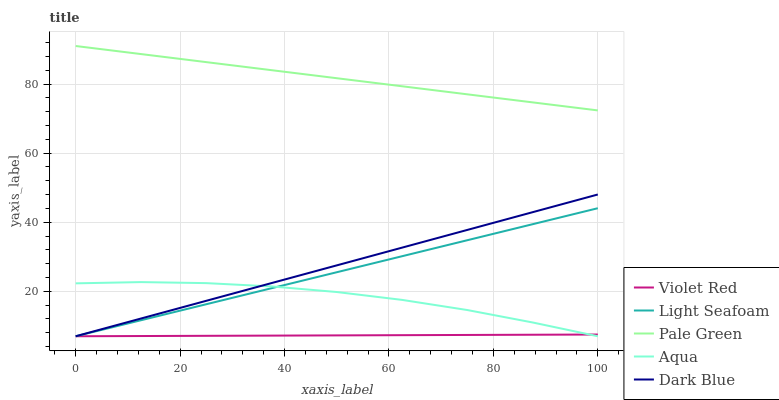Does Violet Red have the minimum area under the curve?
Answer yes or no. Yes. Does Pale Green have the maximum area under the curve?
Answer yes or no. Yes. Does Light Seafoam have the minimum area under the curve?
Answer yes or no. No. Does Light Seafoam have the maximum area under the curve?
Answer yes or no. No. Is Violet Red the smoothest?
Answer yes or no. Yes. Is Aqua the roughest?
Answer yes or no. Yes. Is Light Seafoam the smoothest?
Answer yes or no. No. Is Light Seafoam the roughest?
Answer yes or no. No. Does Violet Red have the lowest value?
Answer yes or no. Yes. Does Pale Green have the highest value?
Answer yes or no. Yes. Does Light Seafoam have the highest value?
Answer yes or no. No. Is Dark Blue less than Pale Green?
Answer yes or no. Yes. Is Pale Green greater than Dark Blue?
Answer yes or no. Yes. Does Aqua intersect Dark Blue?
Answer yes or no. Yes. Is Aqua less than Dark Blue?
Answer yes or no. No. Is Aqua greater than Dark Blue?
Answer yes or no. No. Does Dark Blue intersect Pale Green?
Answer yes or no. No. 